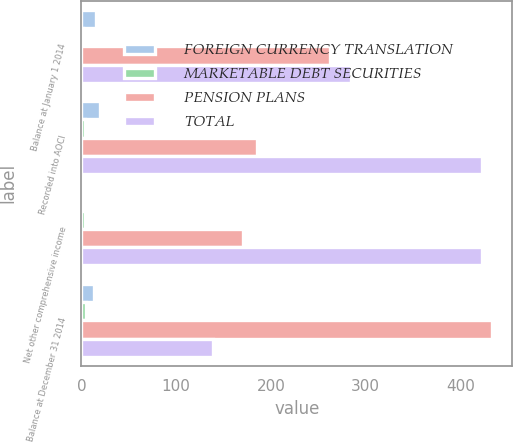<chart> <loc_0><loc_0><loc_500><loc_500><stacked_bar_chart><ecel><fcel>Balance at January 1 2014<fcel>Recorded into AOCI<fcel>Net other comprehensive income<fcel>Balance at December 31 2014<nl><fcel>FOREIGN CURRENCY TRANSLATION<fcel>15.1<fcel>20<fcel>1.6<fcel>13.5<nl><fcel>MARKETABLE DEBT SECURITIES<fcel>1.7<fcel>4.2<fcel>3.6<fcel>5.3<nl><fcel>PENSION PLANS<fcel>262.2<fcel>185.8<fcel>170.9<fcel>433.1<nl><fcel>TOTAL<fcel>284.3<fcel>422.8<fcel>422.8<fcel>138.5<nl></chart> 